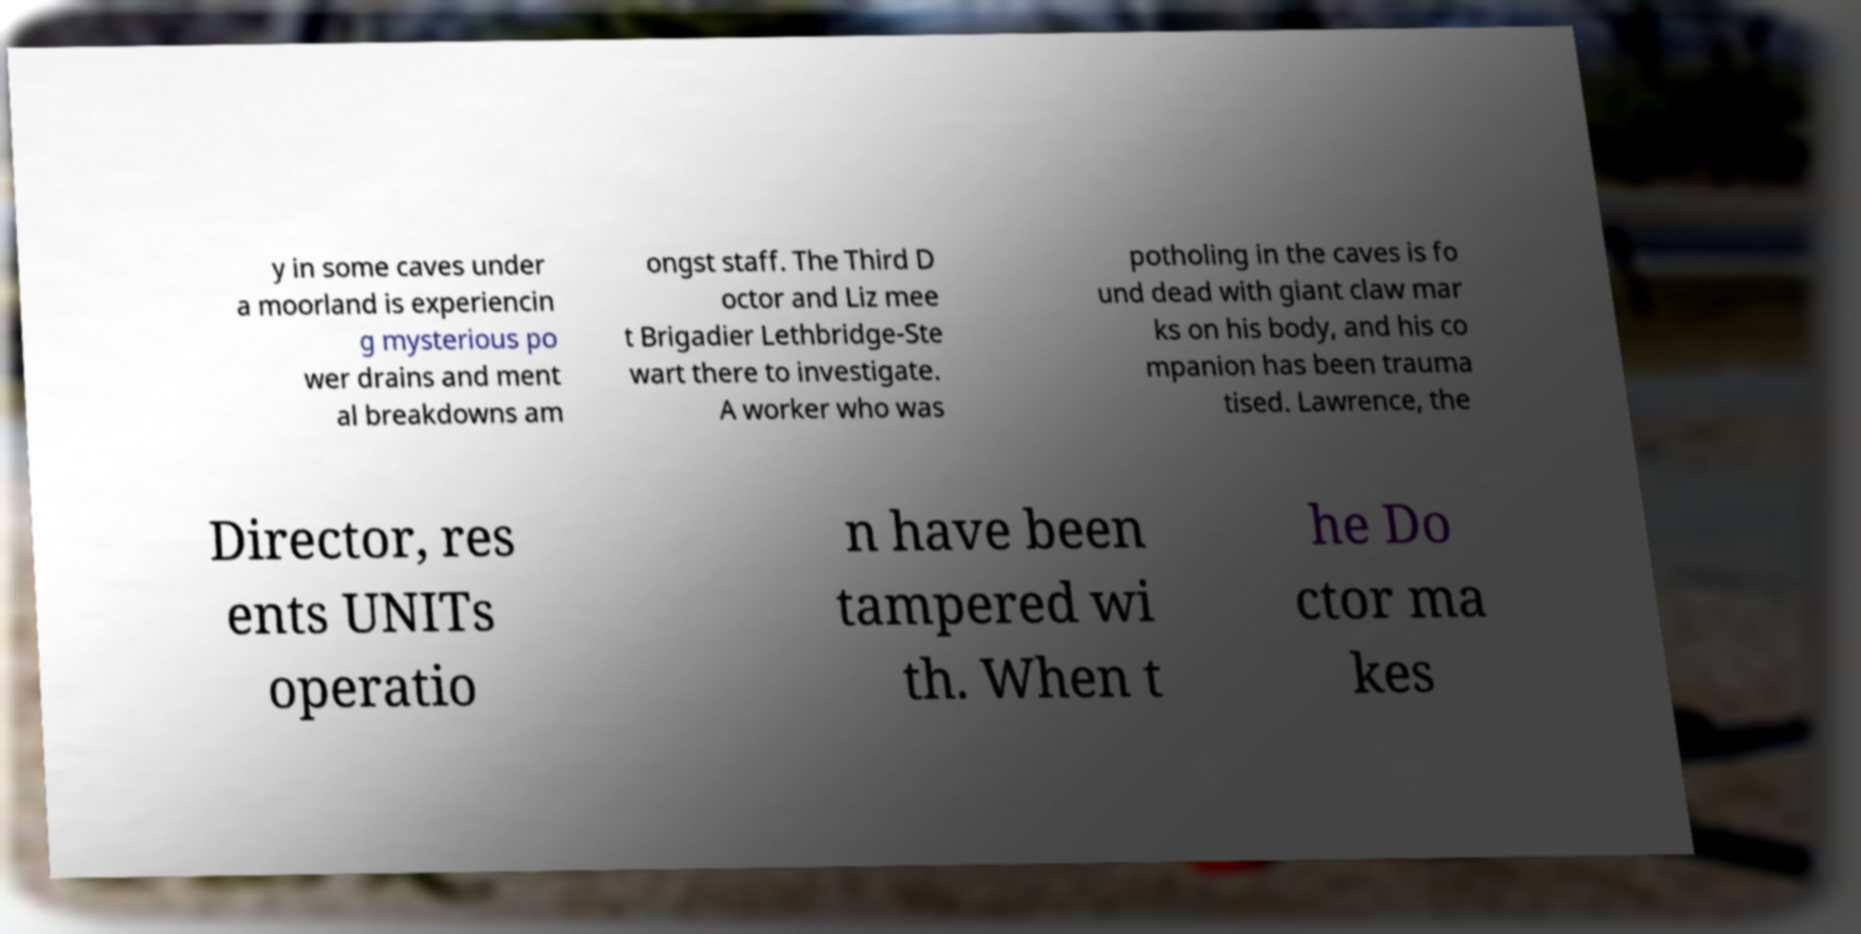I need the written content from this picture converted into text. Can you do that? y in some caves under a moorland is experiencin g mysterious po wer drains and ment al breakdowns am ongst staff. The Third D octor and Liz mee t Brigadier Lethbridge-Ste wart there to investigate. A worker who was potholing in the caves is fo und dead with giant claw mar ks on his body, and his co mpanion has been trauma tised. Lawrence, the Director, res ents UNITs operatio n have been tampered wi th. When t he Do ctor ma kes 